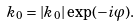<formula> <loc_0><loc_0><loc_500><loc_500>k _ { 0 } = | k _ { 0 } | \exp ( - i \varphi ) .</formula> 